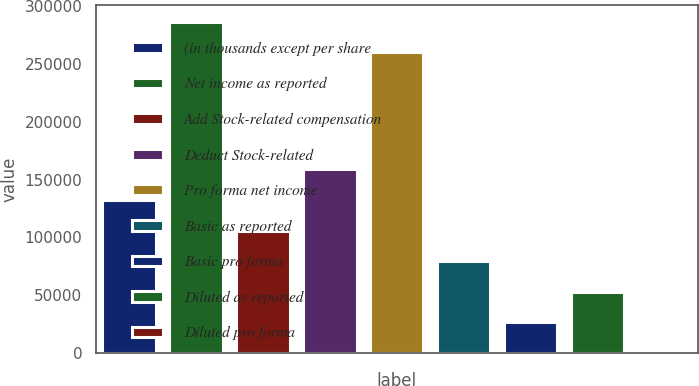<chart> <loc_0><loc_0><loc_500><loc_500><bar_chart><fcel>(in thousands except per share<fcel>Net income as reported<fcel>Add Stock-related compensation<fcel>Deduct Stock-related<fcel>Pro forma net income<fcel>Basic as reported<fcel>Basic pro forma<fcel>Diluted as reported<fcel>Diluted pro forma<nl><fcel>132324<fcel>286549<fcel>105859<fcel>158788<fcel>260085<fcel>79395.2<fcel>26466.7<fcel>52931<fcel>2.44<nl></chart> 